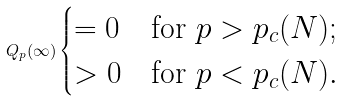Convert formula to latex. <formula><loc_0><loc_0><loc_500><loc_500>Q _ { p } ( \infty ) \begin{cases} = 0 & \text {for $p>p_{c}(N)$} ; \\ > 0 & \text {for $p<p_{c}(N)$} . \end{cases}</formula> 